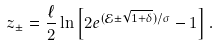<formula> <loc_0><loc_0><loc_500><loc_500>z _ { \pm } = \frac { \ell } { 2 } \ln \left [ 2 e ^ { ( { \mathcal { E } } \pm \sqrt { 1 + \delta } ) / \sigma } - 1 \right ] .</formula> 